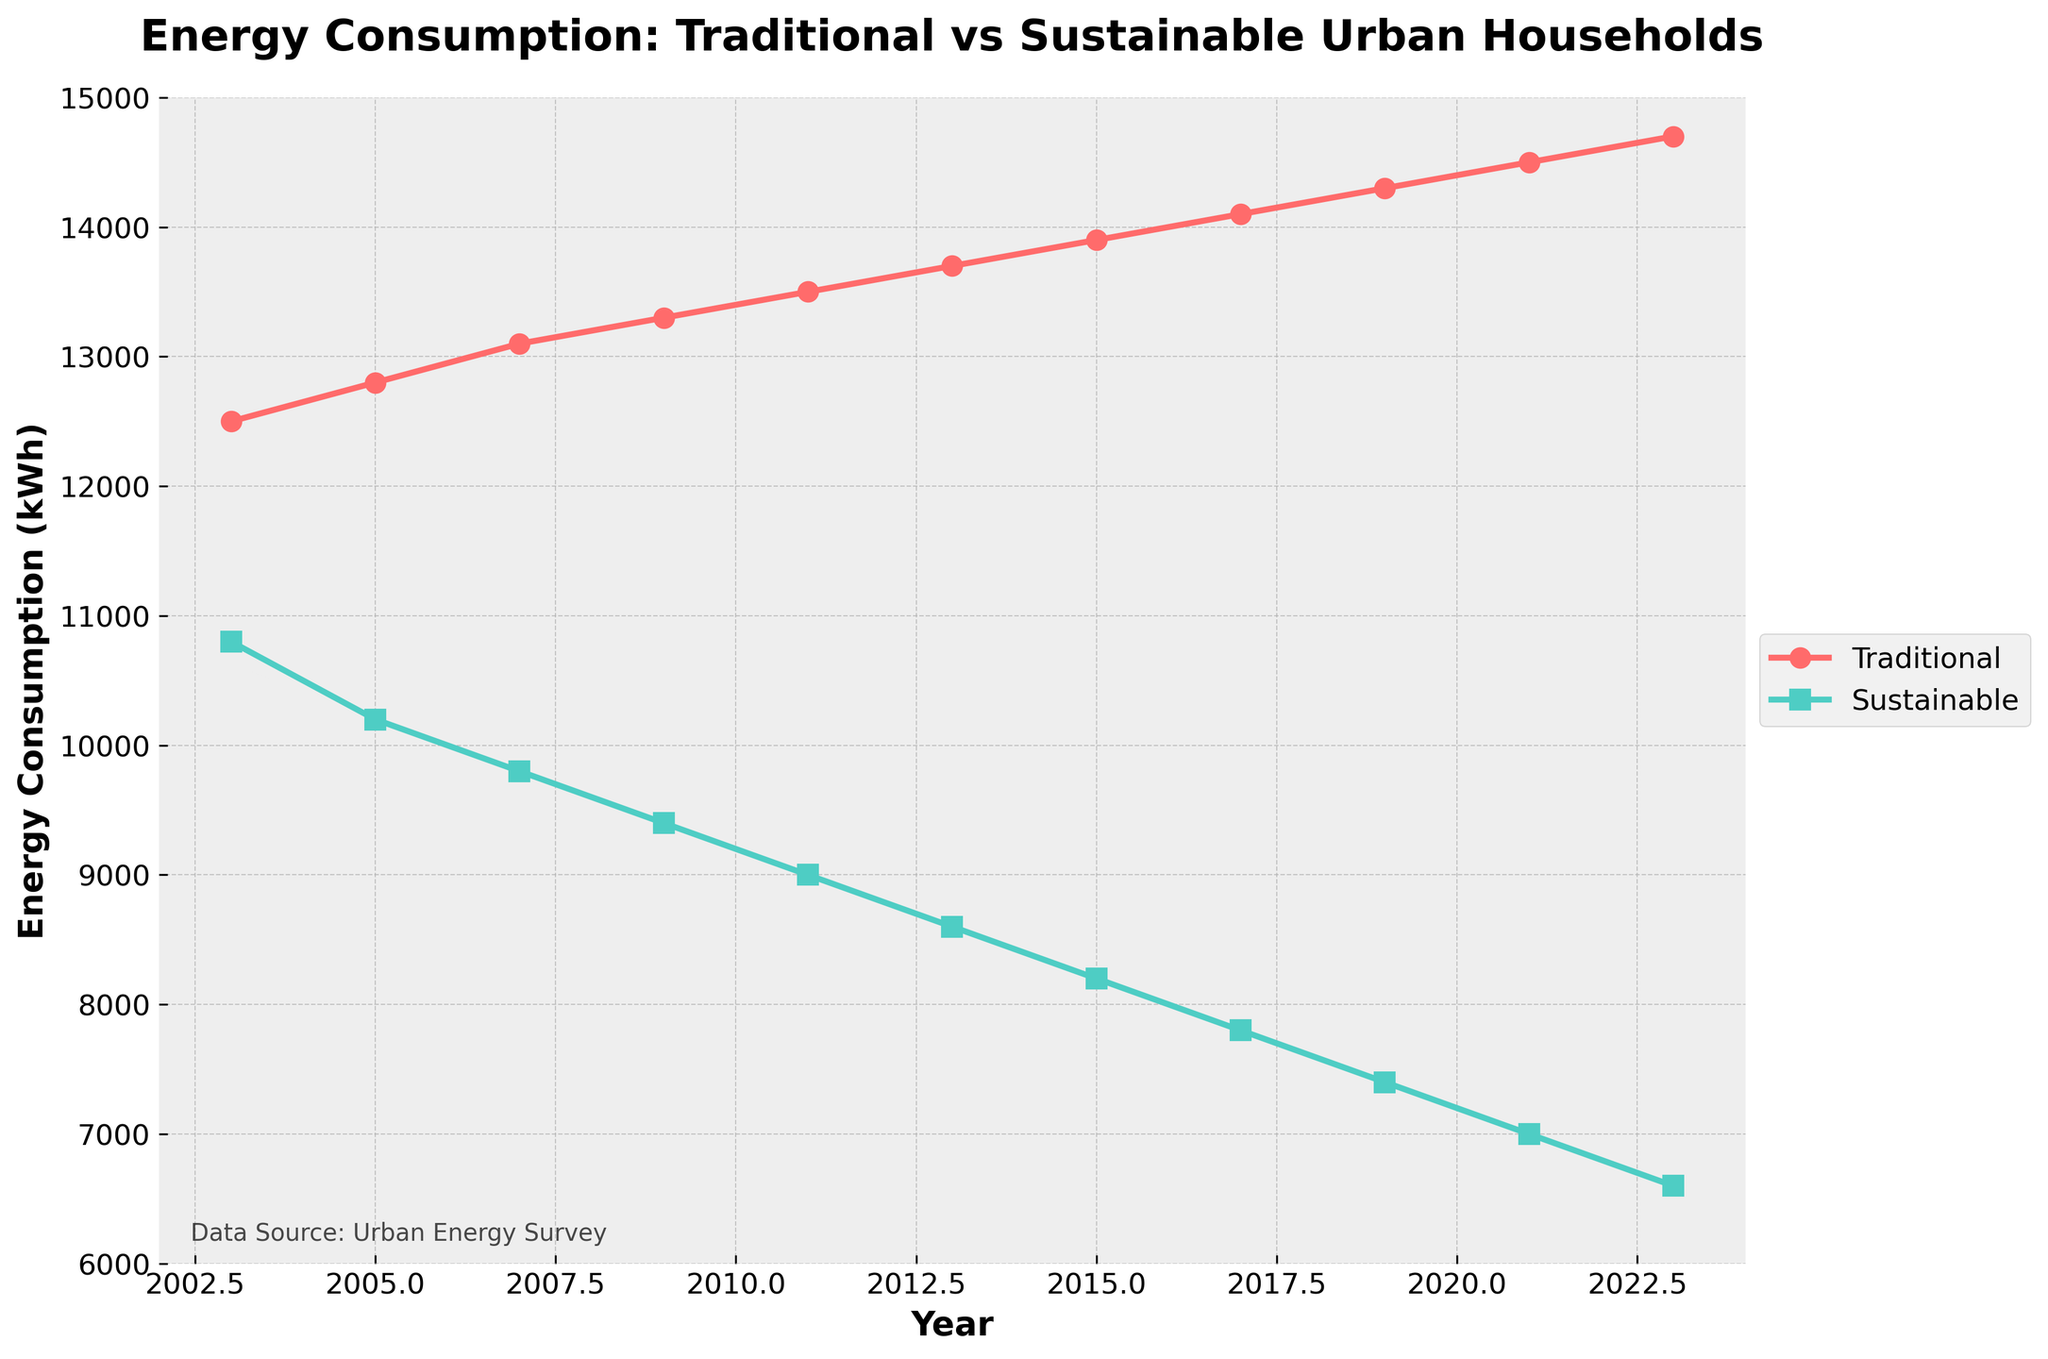Which category of households had a higher energy consumption in 2005? To answer this, we look at the energy consumption values in 2005 for both traditional and sustainable urban households. Traditional households consumed 12800 kWh, while sustainable households consumed 10200 kWh.
Answer: Traditional urban households What's the percentage decrease in energy consumption for sustainable urban households from 2003 to 2023? First, find the initial (2003) and final (2023) values for sustainable urban households: 10800 kWh and 6600 kWh, respectively. The decrease is 10800 - 6600 = 4200 kWh. The percentage decrease is (4200 / 10800) * 100 = 38.89%.
Answer: 38.89% How has the energy consumption trend for traditional urban households changed over the last two decades? Observing the traditional urban households' line from 2003 to 2023, the energy consumption has gradually increased from 12500 kWh to 14700 kWh.
Answer: Gradually increased What was the difference in energy consumption between traditional and sustainable households in 2013? In 2013, traditional households consumed 13700 kWh, and sustainable households consumed 8600 kWh. The difference is 13700 - 8600 = 5100 kWh.
Answer: 5100 kWh In which year did sustainable urban households' energy consumption drop below 10000 kWh for the first time? By viewing the graph, sustainable urban households' energy consumption first dropped below 10000 kWh in 2007 (9800 kWh).
Answer: 2007 Are sustainable urban households consistently using less energy than traditional urban households throughout the last two decades? The graph shows that in every recorded year from 2003 to 2023, the energy consumption of sustainable urban households is consistently lower than that of traditional urban households.
Answer: Yes What's the average yearly decrease in energy consumption for sustainable urban households from 2003 to 2023? Over 20 years (2023-2003), the energy consumption in sustainable households decreased by 10800 kWh - 6600 kWh = 4200 kWh. The average yearly decrease is 4200 kWh / 20 years = 210 kWh per year.
Answer: 210 kWh per year Compare the slope of the lines representing traditional and sustainable urban households over the entire period. The slope of the line for traditional urban households is positive, indicating an increase in energy usage over time. In contrast, the slope of the line for sustainable urban households is negative, indicating a decrease in energy usage over time.
Answer: Traditional increases, Sustainable decreases How much more energy did traditional households consume compared to sustainable households in 2021? In 2021, traditional households consumed 14500 kWh, while sustainable households consumed 7000 kWh. The difference is 14500 - 7000 = 7500 kWh.
Answer: 7500 kWh 